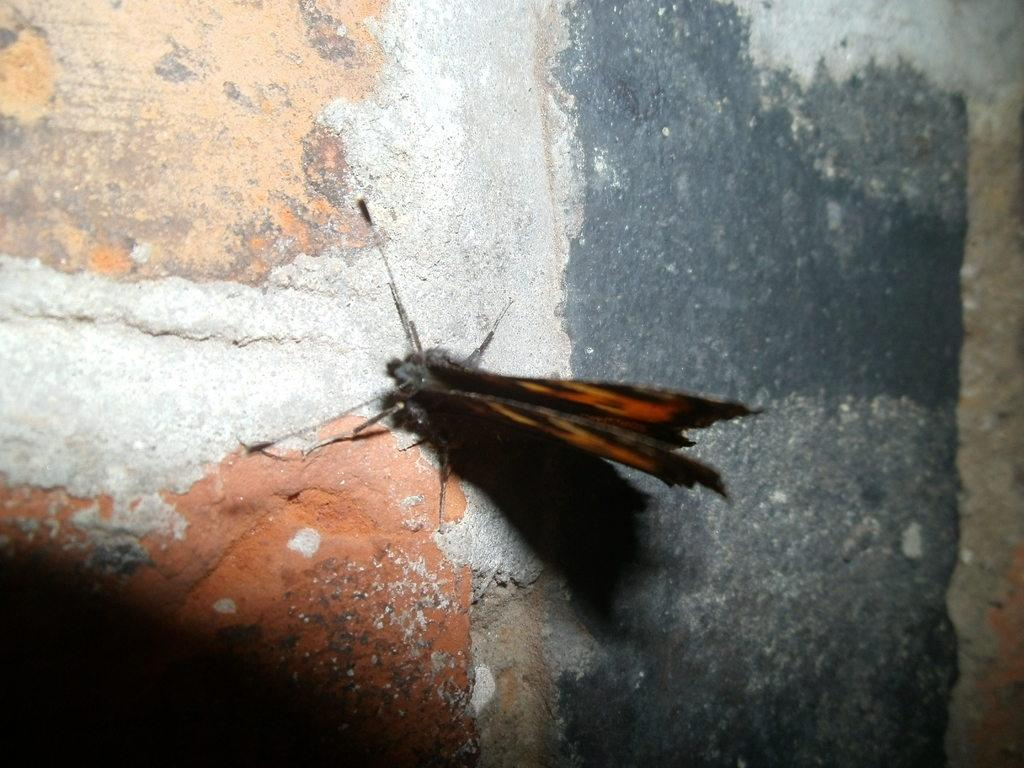What type of creature is present in the image? There is an insect in the image. Can you describe the insect's location in the image? The insect is on a surface in the image. What type of shoes is the insect wearing in the image? There are no shoes present in the image, as the subject is an insect. What news story is the insect reporting on in the image? There is no news story or reporting activity present in the image, as the subject is an insect. 